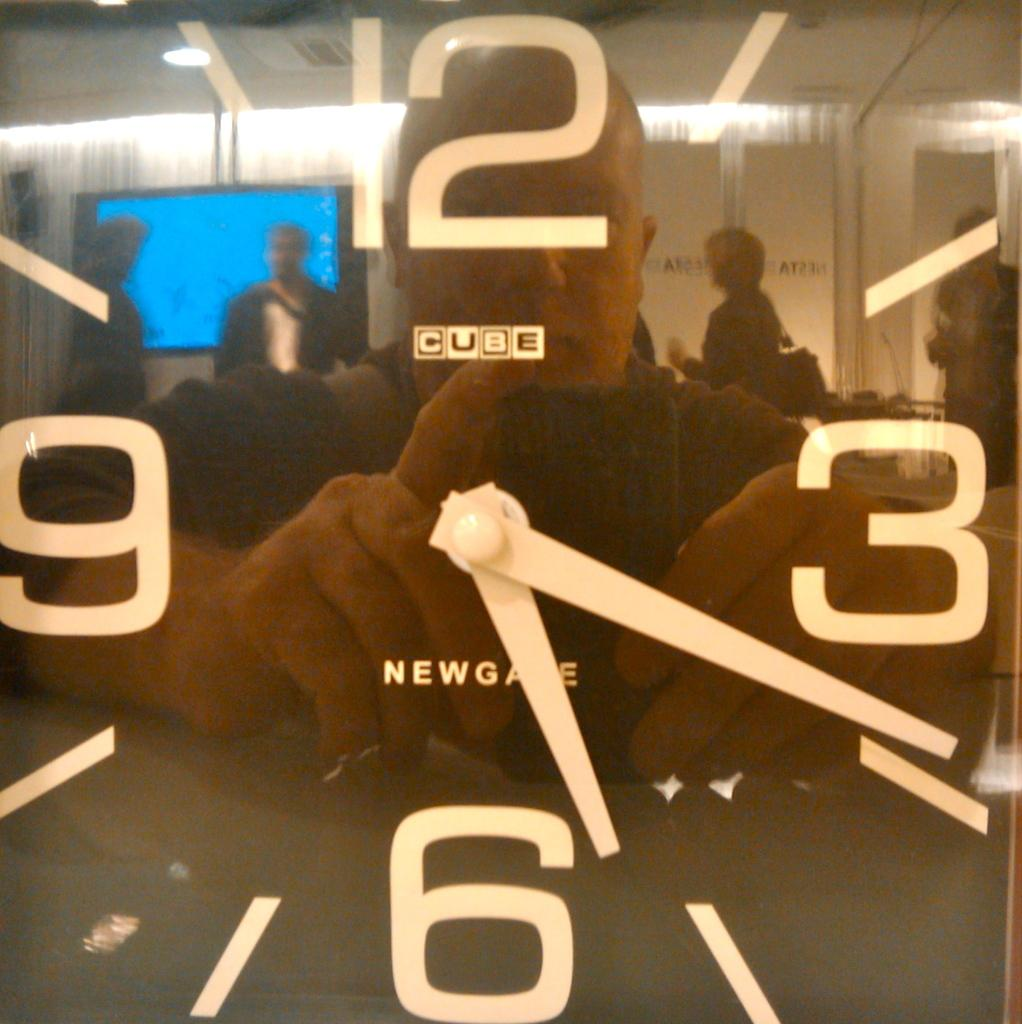What object in the image displays the time? There is a clock in the image that displays the time. What is the man in the image doing? The man is taking a photograph in the reflection of the clock. How many people are visible behind the man? There are multiple people standing behind the man. What electronic device is present in the image? There is a TV screen in the image. What type of rings can be seen on the man's fingers in the image? There are no rings visible on the man's fingers in the image. What force is causing the man to take a photograph in the image? There is no force causing the man to take a photograph; he is doing so voluntarily. 